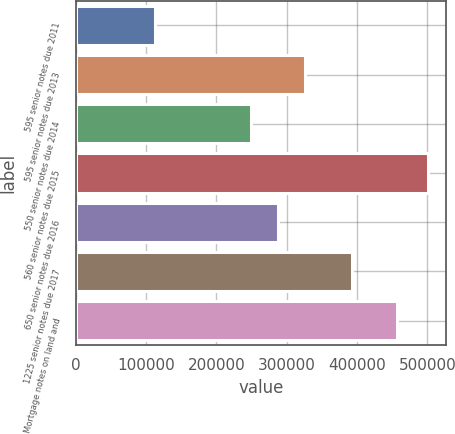<chart> <loc_0><loc_0><loc_500><loc_500><bar_chart><fcel>595 senior notes due 2011<fcel>595 senior notes due 2013<fcel>550 senior notes due 2014<fcel>560 senior notes due 2015<fcel>650 senior notes due 2016<fcel>1225 senior notes due 2017<fcel>Mortgage notes on land and<nl><fcel>113189<fcel>326262<fcel>248657<fcel>501216<fcel>287460<fcel>393031<fcel>456256<nl></chart> 